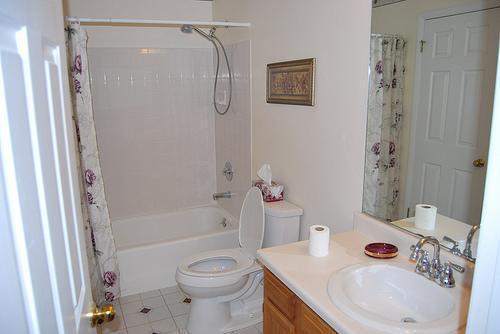How many toilets are in the picture?
Give a very brief answer. 1. 